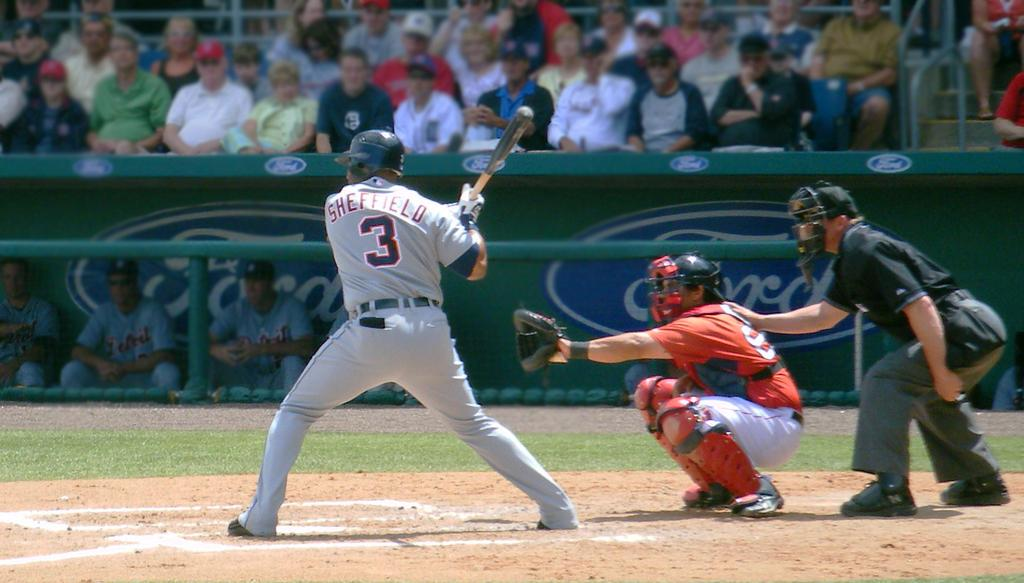Provide a one-sentence caption for the provided image. A batter wears a uniform with number 3 and Sheffield on the back. 